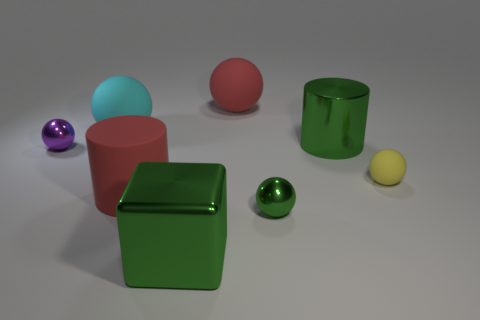Do the rubber cylinder and the big matte sphere that is on the right side of the red cylinder have the same color?
Keep it short and to the point. Yes. Is the shape of the large green metal thing that is on the right side of the big metallic block the same as the big red rubber object that is in front of the purple object?
Your answer should be compact. Yes. What color is the big ball left of the big green metal thing in front of the small metal object that is on the left side of the red cylinder?
Your response must be concise. Cyan. How many other objects are there of the same color as the cube?
Keep it short and to the point. 2. Is the number of small gray shiny things less than the number of large green metal cubes?
Your answer should be compact. Yes. There is a big object that is both behind the big green cylinder and on the right side of the big green shiny block; what color is it?
Provide a short and direct response. Red. There is a yellow object that is the same shape as the small purple thing; what is it made of?
Ensure brevity in your answer.  Rubber. Are there any other things that are the same size as the cyan thing?
Keep it short and to the point. Yes. Is the number of small cyan things greater than the number of tiny things?
Ensure brevity in your answer.  No. There is a object that is both in front of the metallic cylinder and to the left of the large red matte cylinder; how big is it?
Offer a terse response. Small. 